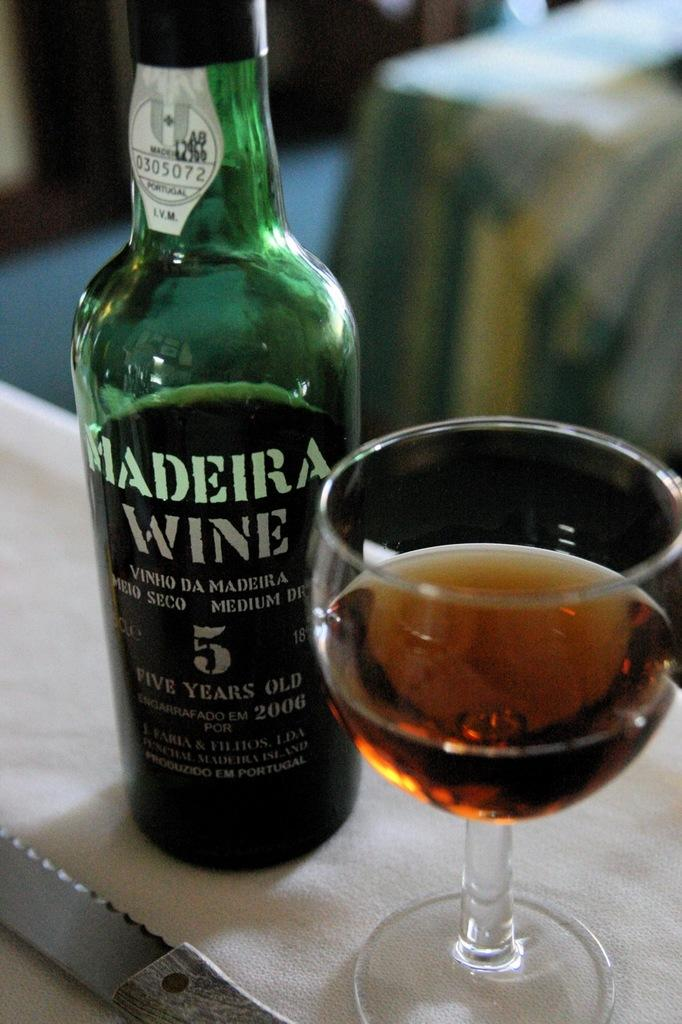<image>
Write a terse but informative summary of the picture. A bottle of Madeira Wine sits next to full wine glass. 